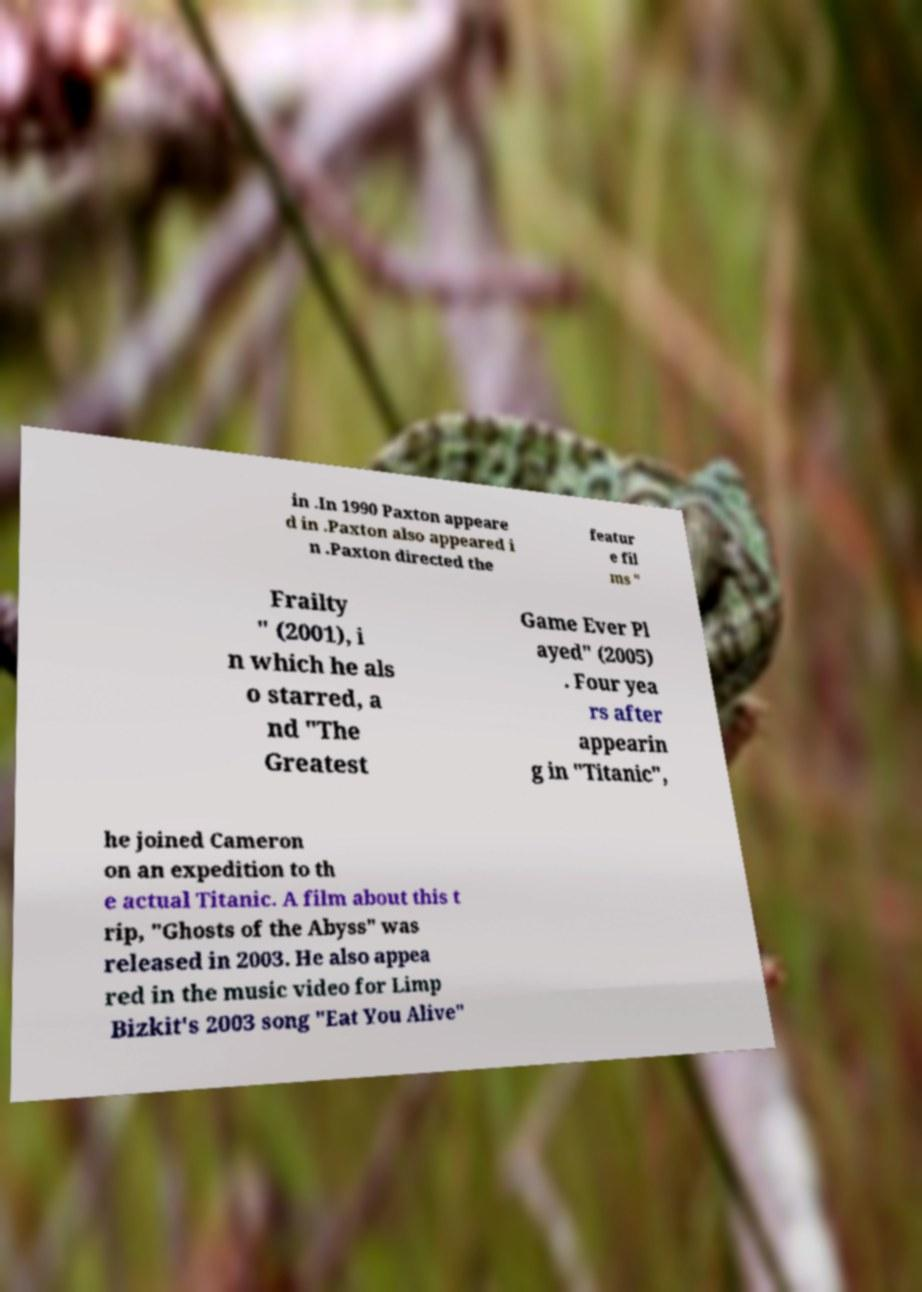I need the written content from this picture converted into text. Can you do that? in .In 1990 Paxton appeare d in .Paxton also appeared i n .Paxton directed the featur e fil ms " Frailty " (2001), i n which he als o starred, a nd "The Greatest Game Ever Pl ayed" (2005) . Four yea rs after appearin g in "Titanic", he joined Cameron on an expedition to th e actual Titanic. A film about this t rip, "Ghosts of the Abyss" was released in 2003. He also appea red in the music video for Limp Bizkit's 2003 song "Eat You Alive" 